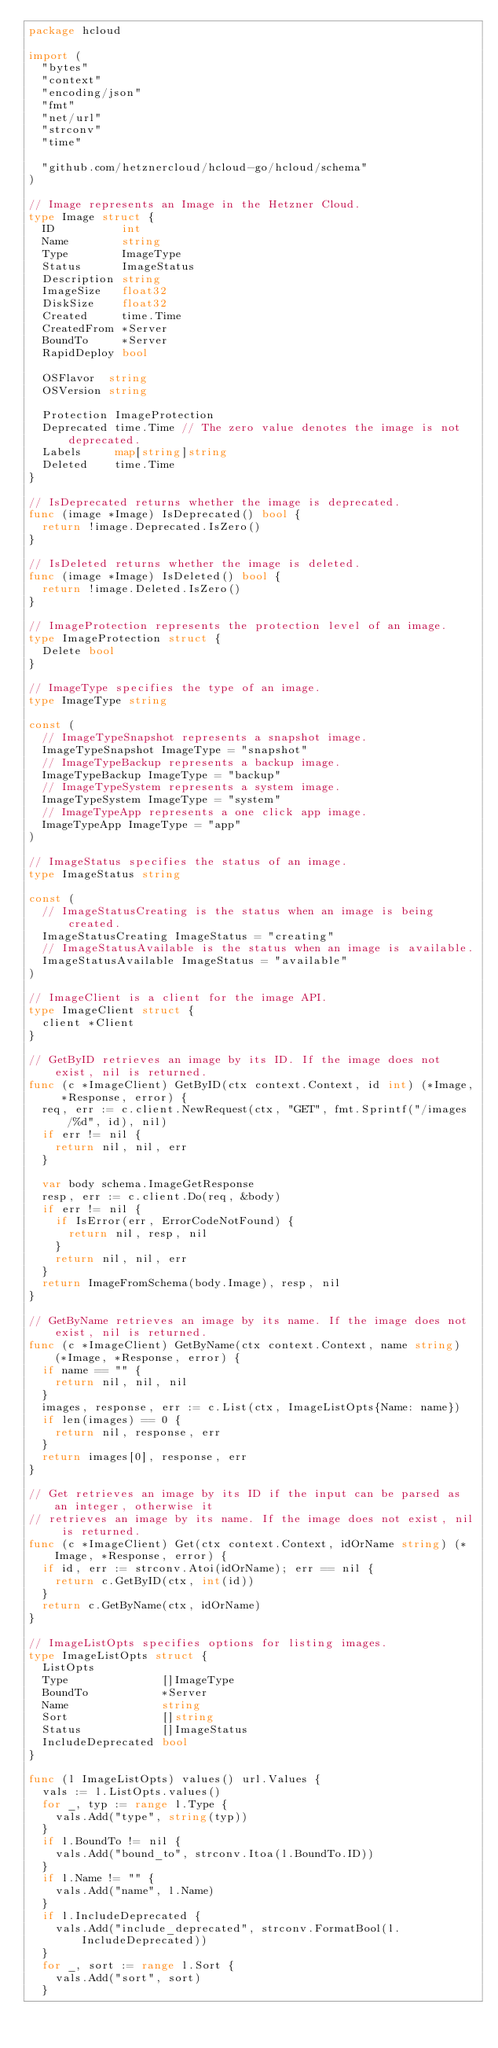Convert code to text. <code><loc_0><loc_0><loc_500><loc_500><_Go_>package hcloud

import (
	"bytes"
	"context"
	"encoding/json"
	"fmt"
	"net/url"
	"strconv"
	"time"

	"github.com/hetznercloud/hcloud-go/hcloud/schema"
)

// Image represents an Image in the Hetzner Cloud.
type Image struct {
	ID          int
	Name        string
	Type        ImageType
	Status      ImageStatus
	Description string
	ImageSize   float32
	DiskSize    float32
	Created     time.Time
	CreatedFrom *Server
	BoundTo     *Server
	RapidDeploy bool

	OSFlavor  string
	OSVersion string

	Protection ImageProtection
	Deprecated time.Time // The zero value denotes the image is not deprecated.
	Labels     map[string]string
	Deleted    time.Time
}

// IsDeprecated returns whether the image is deprecated.
func (image *Image) IsDeprecated() bool {
	return !image.Deprecated.IsZero()
}

// IsDeleted returns whether the image is deleted.
func (image *Image) IsDeleted() bool {
	return !image.Deleted.IsZero()
}

// ImageProtection represents the protection level of an image.
type ImageProtection struct {
	Delete bool
}

// ImageType specifies the type of an image.
type ImageType string

const (
	// ImageTypeSnapshot represents a snapshot image.
	ImageTypeSnapshot ImageType = "snapshot"
	// ImageTypeBackup represents a backup image.
	ImageTypeBackup ImageType = "backup"
	// ImageTypeSystem represents a system image.
	ImageTypeSystem ImageType = "system"
	// ImageTypeApp represents a one click app image.
	ImageTypeApp ImageType = "app"
)

// ImageStatus specifies the status of an image.
type ImageStatus string

const (
	// ImageStatusCreating is the status when an image is being created.
	ImageStatusCreating ImageStatus = "creating"
	// ImageStatusAvailable is the status when an image is available.
	ImageStatusAvailable ImageStatus = "available"
)

// ImageClient is a client for the image API.
type ImageClient struct {
	client *Client
}

// GetByID retrieves an image by its ID. If the image does not exist, nil is returned.
func (c *ImageClient) GetByID(ctx context.Context, id int) (*Image, *Response, error) {
	req, err := c.client.NewRequest(ctx, "GET", fmt.Sprintf("/images/%d", id), nil)
	if err != nil {
		return nil, nil, err
	}

	var body schema.ImageGetResponse
	resp, err := c.client.Do(req, &body)
	if err != nil {
		if IsError(err, ErrorCodeNotFound) {
			return nil, resp, nil
		}
		return nil, nil, err
	}
	return ImageFromSchema(body.Image), resp, nil
}

// GetByName retrieves an image by its name. If the image does not exist, nil is returned.
func (c *ImageClient) GetByName(ctx context.Context, name string) (*Image, *Response, error) {
	if name == "" {
		return nil, nil, nil
	}
	images, response, err := c.List(ctx, ImageListOpts{Name: name})
	if len(images) == 0 {
		return nil, response, err
	}
	return images[0], response, err
}

// Get retrieves an image by its ID if the input can be parsed as an integer, otherwise it
// retrieves an image by its name. If the image does not exist, nil is returned.
func (c *ImageClient) Get(ctx context.Context, idOrName string) (*Image, *Response, error) {
	if id, err := strconv.Atoi(idOrName); err == nil {
		return c.GetByID(ctx, int(id))
	}
	return c.GetByName(ctx, idOrName)
}

// ImageListOpts specifies options for listing images.
type ImageListOpts struct {
	ListOpts
	Type              []ImageType
	BoundTo           *Server
	Name              string
	Sort              []string
	Status            []ImageStatus
	IncludeDeprecated bool
}

func (l ImageListOpts) values() url.Values {
	vals := l.ListOpts.values()
	for _, typ := range l.Type {
		vals.Add("type", string(typ))
	}
	if l.BoundTo != nil {
		vals.Add("bound_to", strconv.Itoa(l.BoundTo.ID))
	}
	if l.Name != "" {
		vals.Add("name", l.Name)
	}
	if l.IncludeDeprecated {
		vals.Add("include_deprecated", strconv.FormatBool(l.IncludeDeprecated))
	}
	for _, sort := range l.Sort {
		vals.Add("sort", sort)
	}</code> 